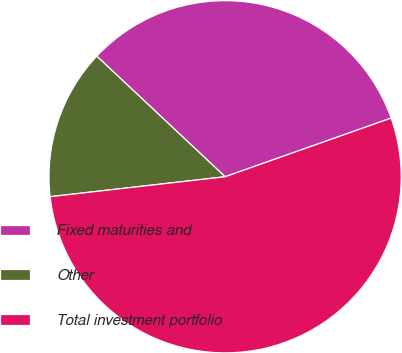Convert chart. <chart><loc_0><loc_0><loc_500><loc_500><pie_chart><fcel>Fixed maturities and<fcel>Other<fcel>Total investment portfolio<nl><fcel>32.59%<fcel>13.81%<fcel>53.6%<nl></chart> 